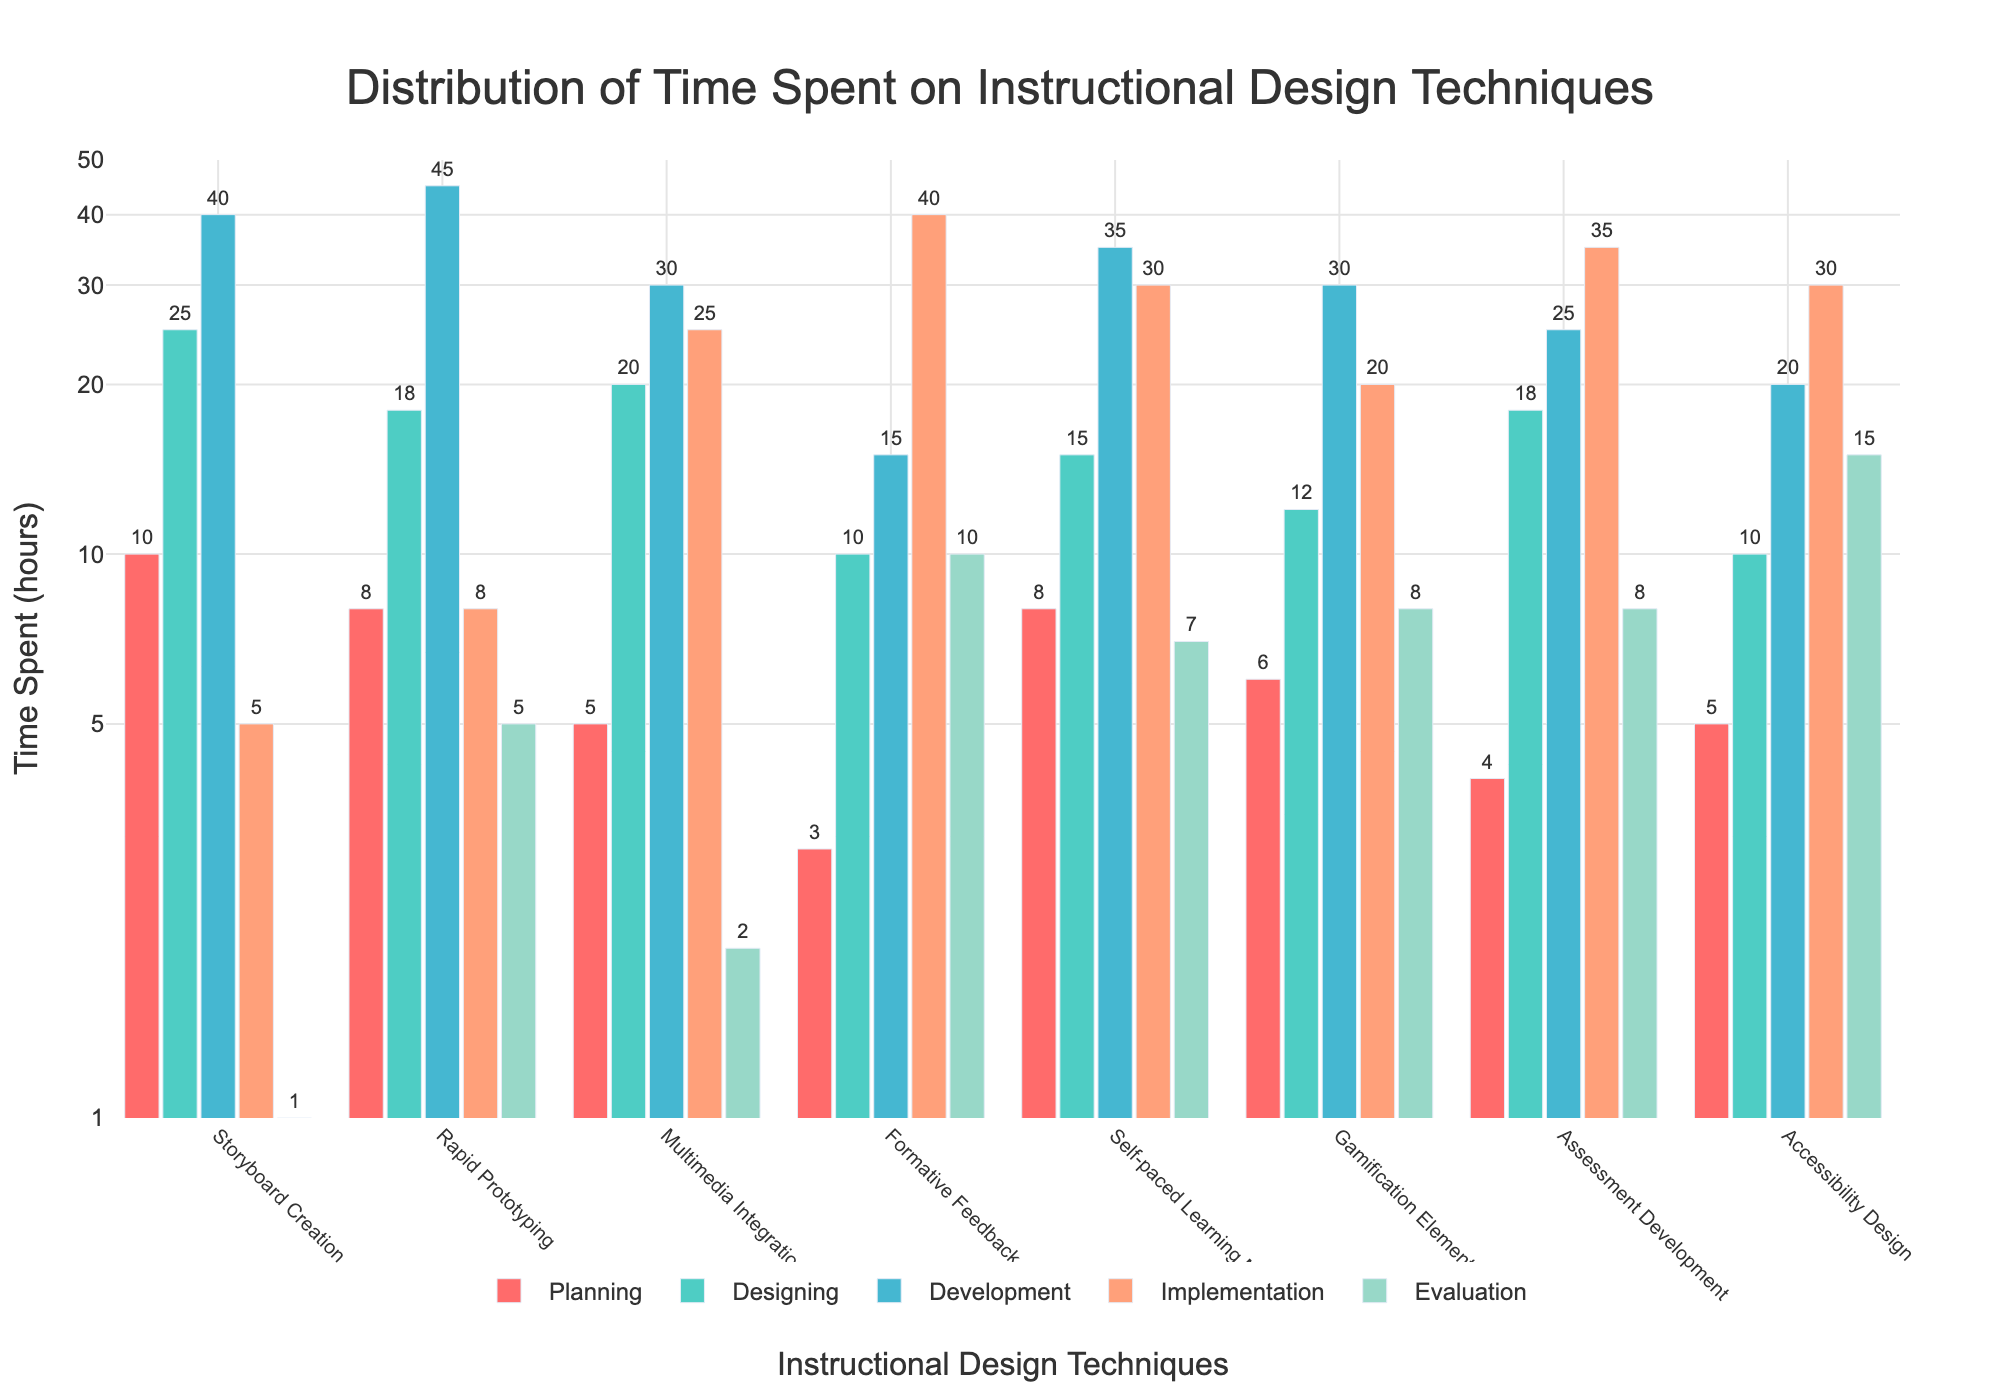What's the title of the plot? The title is located at the top-center of the plot and contains the main summary of what the plot represents. Upon closer examination, the title reads "Distribution of Time Spent on Instructional Design Techniques."
Answer: Distribution of Time Spent on Instructional Design Techniques What is the range of the y-axis? The y-axis is a logarithmic scale and shows labeled ticks. The range can be determined by examining these tick marks from the bottom to the top: it ranges from 0 to 50, although the specific logarithmic transformation is shown instead of linear increments.
Answer: 0 to 50 Which instructional design technique invests the most time in the 'Development' phase? To answer this, examine the bars representing the 'Development' phase for each instructional design technique and identify the tallest one. The tallest bar in the 'Development' section corresponds to 'Rapid Prototyping' at 45 hours.
Answer: Rapid Prototyping What are the color codes used in the plot? This is asking for the distinctive visual information represented by colors for different phases. By examining the legend, we can identify the colors corresponding to phases: Planning (red), Designing (teal), Development (blue), Implementation (orange), Evaluation (green).
Answer: Red, Teal, Blue, Orange, Green Compare the time spent on 'Multimedia Integration' and 'Gamification Elements' techniques during the 'Implementation' phase. Which one takes more time and by how much? To find the answer, compare the 'Implementation' phase values for both techniques. 'Multimedia Integration' has 25 hours while 'Gamification Elements' has 20 hours. Thus, 'Multimedia Integration' takes 5 hours more during the 'Implementation' phase.
Answer: 'Multimedia Integration' takes 5 hours more What is the total amount of time spent on 'Assessment Development' across all phases? Sum the values across all phases for 'Assessment Development': Planning (4), Designing (18), Development (25), Implementation (35), Evaluation (8). Adding them gives 4 + 18 + 25 + 35 + 8 = 90 hours.
Answer: 90 hours During which phase is the highest time spent on 'Formative Feedback'? Examine each phase's bar for 'Formative Feedback' and identify the phase with the tallest bar. The 'Evaluation' phase has the highest value for 'Formative Feedback' at 40 hours.
Answer: Evaluation Which technique spends equal time in the 'Planning' and 'Designing' phases? Look for an instructional design technique that has the same bar height for both the 'Planning' and 'Designing' phases. The 'Self-paced Learning Modules' technique meets this criterion, where both phases have 8 hours each.
Answer: Self-paced Learning Modules What is the time spent on 'Accessibility Design' in the 'Evaluation' phase relative to the 'Development' phase? Compare the values for 'Accessibility Design' in both the 'Evaluation' and 'Development' phases. Evaluation has 15 hours, while Development has 20 hours. The time spent during 'Evaluation' is 5 hours less than in 'Development'.
Answer: 5 hours less Which phase generally has the highest time allocation across most techniques? Visually compare the average height of bars across all phases. The 'Development' phase appears to generally have the tallest bars compared to other phases, indicating higher overall time allocation.
Answer: Development 